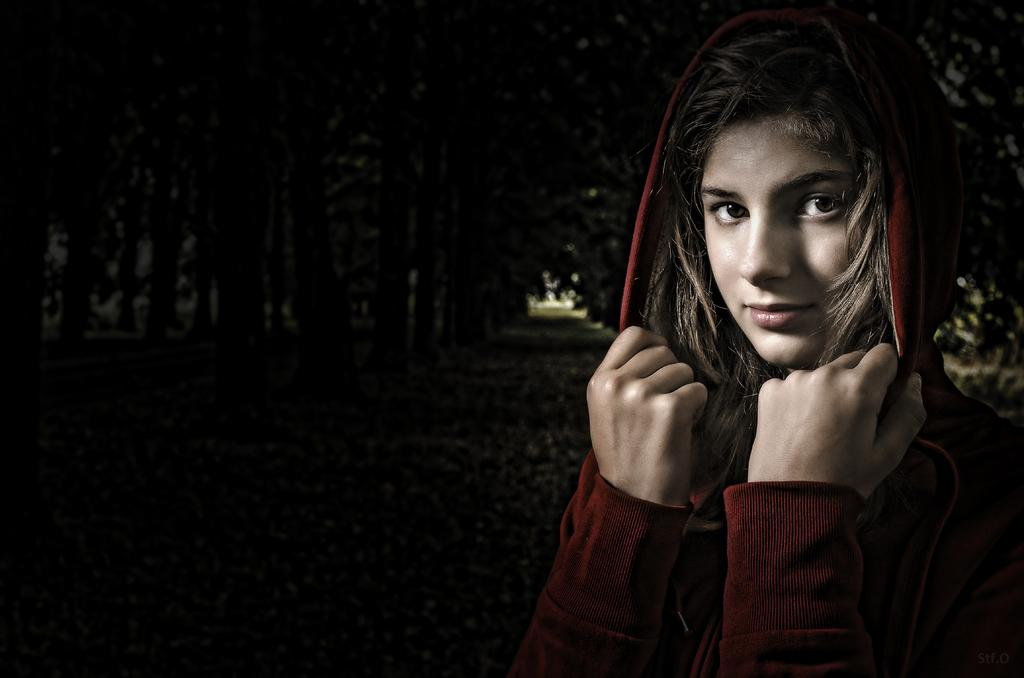Who is the main subject in the foreground of the image? There is a woman in the foreground of the image. What is the woman wearing? The woman is wearing a red hoodie. What is the woman doing with the hoodie? The woman is holding the hoodie. What can be seen in the background of the image? There are trees and pavement visible in the background of the image. How would you describe the lighting in the image? The background is dark. What type of wax is being used to create the stage in the image? There is no stage or wax present in the image. What color is the stage in the image? There is no stage in the image, so it is not possible to determine its color. 